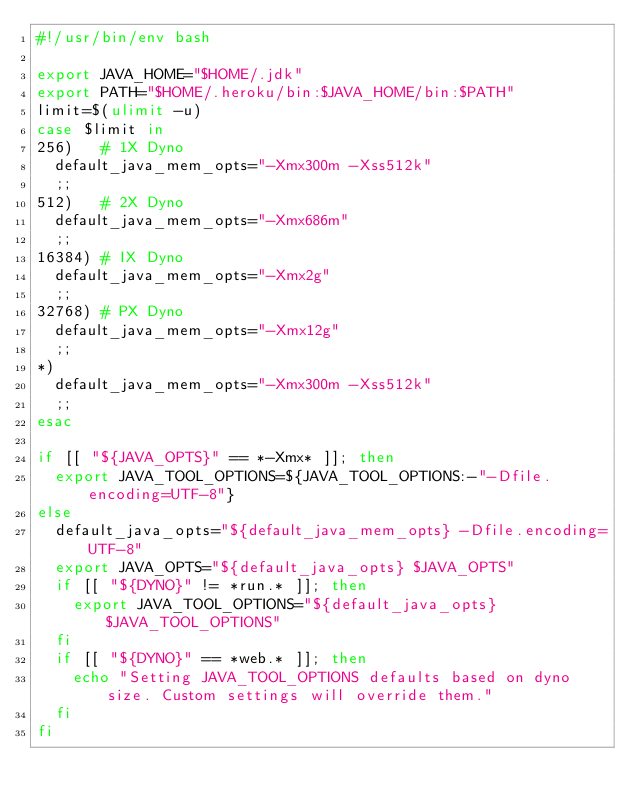<code> <loc_0><loc_0><loc_500><loc_500><_Bash_>#!/usr/bin/env bash

export JAVA_HOME="$HOME/.jdk"
export PATH="$HOME/.heroku/bin:$JAVA_HOME/bin:$PATH"
limit=$(ulimit -u)
case $limit in
256)   # 1X Dyno
  default_java_mem_opts="-Xmx300m -Xss512k"
  ;;
512)   # 2X Dyno
  default_java_mem_opts="-Xmx686m"
  ;;
16384) # IX Dyno
  default_java_mem_opts="-Xmx2g"
  ;;
32768) # PX Dyno
  default_java_mem_opts="-Xmx12g"
  ;;
*)
  default_java_mem_opts="-Xmx300m -Xss512k"
  ;;
esac

if [[ "${JAVA_OPTS}" == *-Xmx* ]]; then
  export JAVA_TOOL_OPTIONS=${JAVA_TOOL_OPTIONS:-"-Dfile.encoding=UTF-8"}
else
  default_java_opts="${default_java_mem_opts} -Dfile.encoding=UTF-8"
  export JAVA_OPTS="${default_java_opts} $JAVA_OPTS"
  if [[ "${DYNO}" != *run.* ]]; then
    export JAVA_TOOL_OPTIONS="${default_java_opts} $JAVA_TOOL_OPTIONS"
  fi
  if [[ "${DYNO}" == *web.* ]]; then
    echo "Setting JAVA_TOOL_OPTIONS defaults based on dyno size. Custom settings will override them."
  fi
fi
</code> 